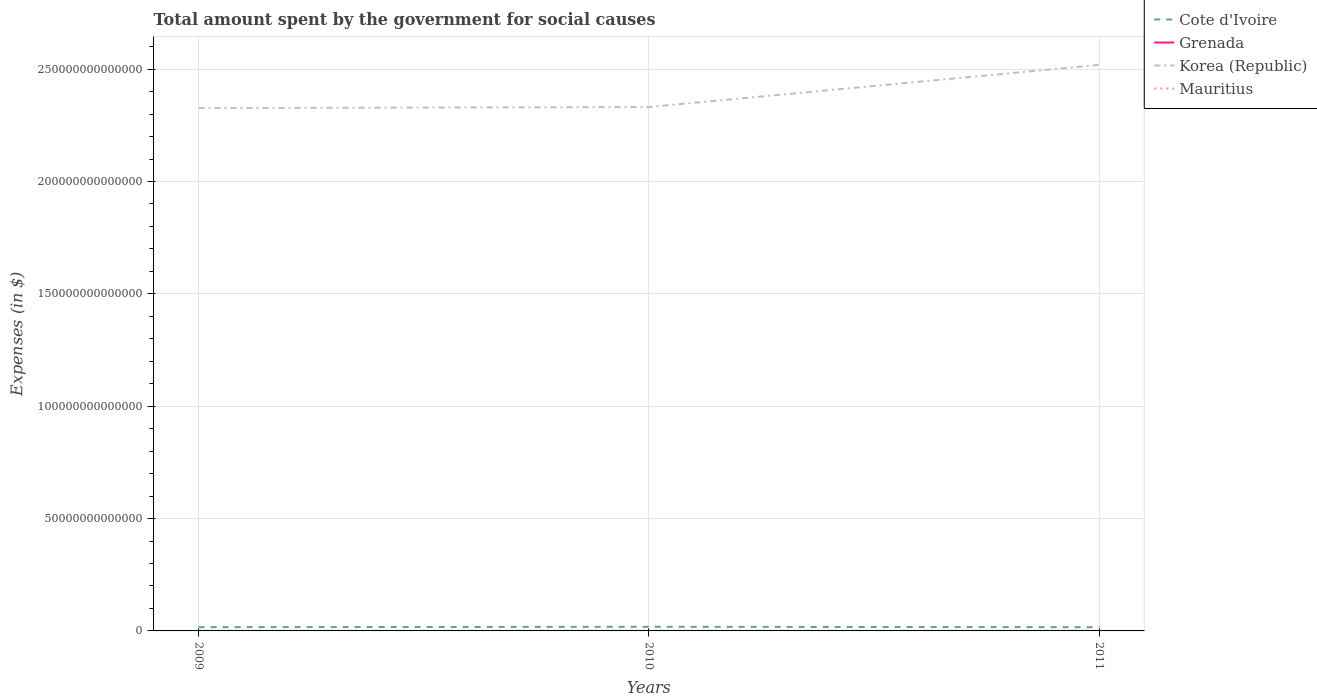Does the line corresponding to Cote d'Ivoire intersect with the line corresponding to Mauritius?
Ensure brevity in your answer.  No. Across all years, what is the maximum amount spent for social causes by the government in Mauritius?
Give a very brief answer. 6.11e+1. What is the total amount spent for social causes by the government in Cote d'Ivoire in the graph?
Your response must be concise. -1.67e+11. What is the difference between the highest and the second highest amount spent for social causes by the government in Cote d'Ivoire?
Keep it short and to the point. 1.75e+11. Is the amount spent for social causes by the government in Grenada strictly greater than the amount spent for social causes by the government in Korea (Republic) over the years?
Give a very brief answer. Yes. How many lines are there?
Your response must be concise. 4. How many years are there in the graph?
Offer a terse response. 3. What is the difference between two consecutive major ticks on the Y-axis?
Offer a very short reply. 5.00e+13. Where does the legend appear in the graph?
Provide a succinct answer. Top right. How many legend labels are there?
Your answer should be compact. 4. What is the title of the graph?
Your answer should be very brief. Total amount spent by the government for social causes. What is the label or title of the X-axis?
Ensure brevity in your answer.  Years. What is the label or title of the Y-axis?
Keep it short and to the point. Expenses (in $). What is the Expenses (in $) in Cote d'Ivoire in 2009?
Ensure brevity in your answer.  1.67e+12. What is the Expenses (in $) of Grenada in 2009?
Ensure brevity in your answer.  4.17e+08. What is the Expenses (in $) in Korea (Republic) in 2009?
Offer a terse response. 2.33e+14. What is the Expenses (in $) of Mauritius in 2009?
Give a very brief answer. 6.11e+1. What is the Expenses (in $) in Cote d'Ivoire in 2010?
Your response must be concise. 1.84e+12. What is the Expenses (in $) in Grenada in 2010?
Give a very brief answer. 4.08e+08. What is the Expenses (in $) in Korea (Republic) in 2010?
Ensure brevity in your answer.  2.33e+14. What is the Expenses (in $) of Mauritius in 2010?
Provide a short and direct response. 6.78e+1. What is the Expenses (in $) in Cote d'Ivoire in 2011?
Offer a terse response. 1.66e+12. What is the Expenses (in $) in Grenada in 2011?
Ensure brevity in your answer.  4.21e+08. What is the Expenses (in $) in Korea (Republic) in 2011?
Provide a succinct answer. 2.52e+14. What is the Expenses (in $) of Mauritius in 2011?
Your response must be concise. 6.75e+1. Across all years, what is the maximum Expenses (in $) in Cote d'Ivoire?
Ensure brevity in your answer.  1.84e+12. Across all years, what is the maximum Expenses (in $) of Grenada?
Provide a short and direct response. 4.21e+08. Across all years, what is the maximum Expenses (in $) in Korea (Republic)?
Keep it short and to the point. 2.52e+14. Across all years, what is the maximum Expenses (in $) in Mauritius?
Your answer should be very brief. 6.78e+1. Across all years, what is the minimum Expenses (in $) of Cote d'Ivoire?
Offer a very short reply. 1.66e+12. Across all years, what is the minimum Expenses (in $) of Grenada?
Your answer should be compact. 4.08e+08. Across all years, what is the minimum Expenses (in $) in Korea (Republic)?
Offer a terse response. 2.33e+14. Across all years, what is the minimum Expenses (in $) of Mauritius?
Your response must be concise. 6.11e+1. What is the total Expenses (in $) of Cote d'Ivoire in the graph?
Provide a short and direct response. 5.17e+12. What is the total Expenses (in $) in Grenada in the graph?
Your answer should be compact. 1.25e+09. What is the total Expenses (in $) in Korea (Republic) in the graph?
Offer a terse response. 7.18e+14. What is the total Expenses (in $) of Mauritius in the graph?
Provide a short and direct response. 1.96e+11. What is the difference between the Expenses (in $) in Cote d'Ivoire in 2009 and that in 2010?
Provide a succinct answer. -1.67e+11. What is the difference between the Expenses (in $) of Grenada in 2009 and that in 2010?
Your answer should be compact. 8.10e+06. What is the difference between the Expenses (in $) in Korea (Republic) in 2009 and that in 2010?
Your answer should be very brief. -4.79e+11. What is the difference between the Expenses (in $) in Mauritius in 2009 and that in 2010?
Offer a very short reply. -6.67e+09. What is the difference between the Expenses (in $) of Cote d'Ivoire in 2009 and that in 2011?
Your answer should be very brief. 8.24e+09. What is the difference between the Expenses (in $) in Grenada in 2009 and that in 2011?
Provide a short and direct response. -4.20e+06. What is the difference between the Expenses (in $) of Korea (Republic) in 2009 and that in 2011?
Give a very brief answer. -1.92e+13. What is the difference between the Expenses (in $) of Mauritius in 2009 and that in 2011?
Keep it short and to the point. -6.32e+09. What is the difference between the Expenses (in $) of Cote d'Ivoire in 2010 and that in 2011?
Ensure brevity in your answer.  1.75e+11. What is the difference between the Expenses (in $) of Grenada in 2010 and that in 2011?
Offer a terse response. -1.23e+07. What is the difference between the Expenses (in $) of Korea (Republic) in 2010 and that in 2011?
Keep it short and to the point. -1.88e+13. What is the difference between the Expenses (in $) of Mauritius in 2010 and that in 2011?
Offer a very short reply. 3.55e+08. What is the difference between the Expenses (in $) in Cote d'Ivoire in 2009 and the Expenses (in $) in Grenada in 2010?
Provide a succinct answer. 1.67e+12. What is the difference between the Expenses (in $) in Cote d'Ivoire in 2009 and the Expenses (in $) in Korea (Republic) in 2010?
Your answer should be very brief. -2.31e+14. What is the difference between the Expenses (in $) of Cote d'Ivoire in 2009 and the Expenses (in $) of Mauritius in 2010?
Offer a terse response. 1.60e+12. What is the difference between the Expenses (in $) in Grenada in 2009 and the Expenses (in $) in Korea (Republic) in 2010?
Give a very brief answer. -2.33e+14. What is the difference between the Expenses (in $) in Grenada in 2009 and the Expenses (in $) in Mauritius in 2010?
Provide a short and direct response. -6.74e+1. What is the difference between the Expenses (in $) of Korea (Republic) in 2009 and the Expenses (in $) of Mauritius in 2010?
Give a very brief answer. 2.33e+14. What is the difference between the Expenses (in $) of Cote d'Ivoire in 2009 and the Expenses (in $) of Grenada in 2011?
Make the answer very short. 1.67e+12. What is the difference between the Expenses (in $) in Cote d'Ivoire in 2009 and the Expenses (in $) in Korea (Republic) in 2011?
Provide a succinct answer. -2.50e+14. What is the difference between the Expenses (in $) in Cote d'Ivoire in 2009 and the Expenses (in $) in Mauritius in 2011?
Make the answer very short. 1.60e+12. What is the difference between the Expenses (in $) in Grenada in 2009 and the Expenses (in $) in Korea (Republic) in 2011?
Give a very brief answer. -2.52e+14. What is the difference between the Expenses (in $) of Grenada in 2009 and the Expenses (in $) of Mauritius in 2011?
Provide a succinct answer. -6.70e+1. What is the difference between the Expenses (in $) of Korea (Republic) in 2009 and the Expenses (in $) of Mauritius in 2011?
Your answer should be compact. 2.33e+14. What is the difference between the Expenses (in $) of Cote d'Ivoire in 2010 and the Expenses (in $) of Grenada in 2011?
Give a very brief answer. 1.84e+12. What is the difference between the Expenses (in $) of Cote d'Ivoire in 2010 and the Expenses (in $) of Korea (Republic) in 2011?
Offer a very short reply. -2.50e+14. What is the difference between the Expenses (in $) in Cote d'Ivoire in 2010 and the Expenses (in $) in Mauritius in 2011?
Offer a very short reply. 1.77e+12. What is the difference between the Expenses (in $) in Grenada in 2010 and the Expenses (in $) in Korea (Republic) in 2011?
Your response must be concise. -2.52e+14. What is the difference between the Expenses (in $) in Grenada in 2010 and the Expenses (in $) in Mauritius in 2011?
Your answer should be very brief. -6.70e+1. What is the difference between the Expenses (in $) in Korea (Republic) in 2010 and the Expenses (in $) in Mauritius in 2011?
Offer a very short reply. 2.33e+14. What is the average Expenses (in $) in Cote d'Ivoire per year?
Your answer should be compact. 1.72e+12. What is the average Expenses (in $) of Grenada per year?
Make the answer very short. 4.15e+08. What is the average Expenses (in $) in Korea (Republic) per year?
Keep it short and to the point. 2.39e+14. What is the average Expenses (in $) in Mauritius per year?
Your response must be concise. 6.55e+1. In the year 2009, what is the difference between the Expenses (in $) of Cote d'Ivoire and Expenses (in $) of Grenada?
Offer a terse response. 1.67e+12. In the year 2009, what is the difference between the Expenses (in $) of Cote d'Ivoire and Expenses (in $) of Korea (Republic)?
Ensure brevity in your answer.  -2.31e+14. In the year 2009, what is the difference between the Expenses (in $) of Cote d'Ivoire and Expenses (in $) of Mauritius?
Keep it short and to the point. 1.61e+12. In the year 2009, what is the difference between the Expenses (in $) of Grenada and Expenses (in $) of Korea (Republic)?
Keep it short and to the point. -2.33e+14. In the year 2009, what is the difference between the Expenses (in $) of Grenada and Expenses (in $) of Mauritius?
Provide a short and direct response. -6.07e+1. In the year 2009, what is the difference between the Expenses (in $) in Korea (Republic) and Expenses (in $) in Mauritius?
Offer a very short reply. 2.33e+14. In the year 2010, what is the difference between the Expenses (in $) of Cote d'Ivoire and Expenses (in $) of Grenada?
Provide a succinct answer. 1.84e+12. In the year 2010, what is the difference between the Expenses (in $) of Cote d'Ivoire and Expenses (in $) of Korea (Republic)?
Offer a terse response. -2.31e+14. In the year 2010, what is the difference between the Expenses (in $) of Cote d'Ivoire and Expenses (in $) of Mauritius?
Offer a very short reply. 1.77e+12. In the year 2010, what is the difference between the Expenses (in $) in Grenada and Expenses (in $) in Korea (Republic)?
Provide a succinct answer. -2.33e+14. In the year 2010, what is the difference between the Expenses (in $) in Grenada and Expenses (in $) in Mauritius?
Ensure brevity in your answer.  -6.74e+1. In the year 2010, what is the difference between the Expenses (in $) in Korea (Republic) and Expenses (in $) in Mauritius?
Make the answer very short. 2.33e+14. In the year 2011, what is the difference between the Expenses (in $) of Cote d'Ivoire and Expenses (in $) of Grenada?
Keep it short and to the point. 1.66e+12. In the year 2011, what is the difference between the Expenses (in $) of Cote d'Ivoire and Expenses (in $) of Korea (Republic)?
Ensure brevity in your answer.  -2.50e+14. In the year 2011, what is the difference between the Expenses (in $) in Cote d'Ivoire and Expenses (in $) in Mauritius?
Provide a succinct answer. 1.59e+12. In the year 2011, what is the difference between the Expenses (in $) in Grenada and Expenses (in $) in Korea (Republic)?
Offer a terse response. -2.52e+14. In the year 2011, what is the difference between the Expenses (in $) in Grenada and Expenses (in $) in Mauritius?
Provide a succinct answer. -6.70e+1. In the year 2011, what is the difference between the Expenses (in $) in Korea (Republic) and Expenses (in $) in Mauritius?
Make the answer very short. 2.52e+14. What is the ratio of the Expenses (in $) in Cote d'Ivoire in 2009 to that in 2010?
Offer a terse response. 0.91. What is the ratio of the Expenses (in $) of Grenada in 2009 to that in 2010?
Keep it short and to the point. 1.02. What is the ratio of the Expenses (in $) of Korea (Republic) in 2009 to that in 2010?
Your response must be concise. 1. What is the ratio of the Expenses (in $) of Mauritius in 2009 to that in 2010?
Your answer should be very brief. 0.9. What is the ratio of the Expenses (in $) in Grenada in 2009 to that in 2011?
Provide a succinct answer. 0.99. What is the ratio of the Expenses (in $) in Korea (Republic) in 2009 to that in 2011?
Provide a short and direct response. 0.92. What is the ratio of the Expenses (in $) in Mauritius in 2009 to that in 2011?
Make the answer very short. 0.91. What is the ratio of the Expenses (in $) in Cote d'Ivoire in 2010 to that in 2011?
Your answer should be very brief. 1.11. What is the ratio of the Expenses (in $) in Grenada in 2010 to that in 2011?
Your response must be concise. 0.97. What is the ratio of the Expenses (in $) of Korea (Republic) in 2010 to that in 2011?
Offer a terse response. 0.93. What is the difference between the highest and the second highest Expenses (in $) in Cote d'Ivoire?
Offer a terse response. 1.67e+11. What is the difference between the highest and the second highest Expenses (in $) in Grenada?
Keep it short and to the point. 4.20e+06. What is the difference between the highest and the second highest Expenses (in $) of Korea (Republic)?
Offer a terse response. 1.88e+13. What is the difference between the highest and the second highest Expenses (in $) of Mauritius?
Your response must be concise. 3.55e+08. What is the difference between the highest and the lowest Expenses (in $) of Cote d'Ivoire?
Provide a short and direct response. 1.75e+11. What is the difference between the highest and the lowest Expenses (in $) of Grenada?
Ensure brevity in your answer.  1.23e+07. What is the difference between the highest and the lowest Expenses (in $) in Korea (Republic)?
Keep it short and to the point. 1.92e+13. What is the difference between the highest and the lowest Expenses (in $) of Mauritius?
Give a very brief answer. 6.67e+09. 